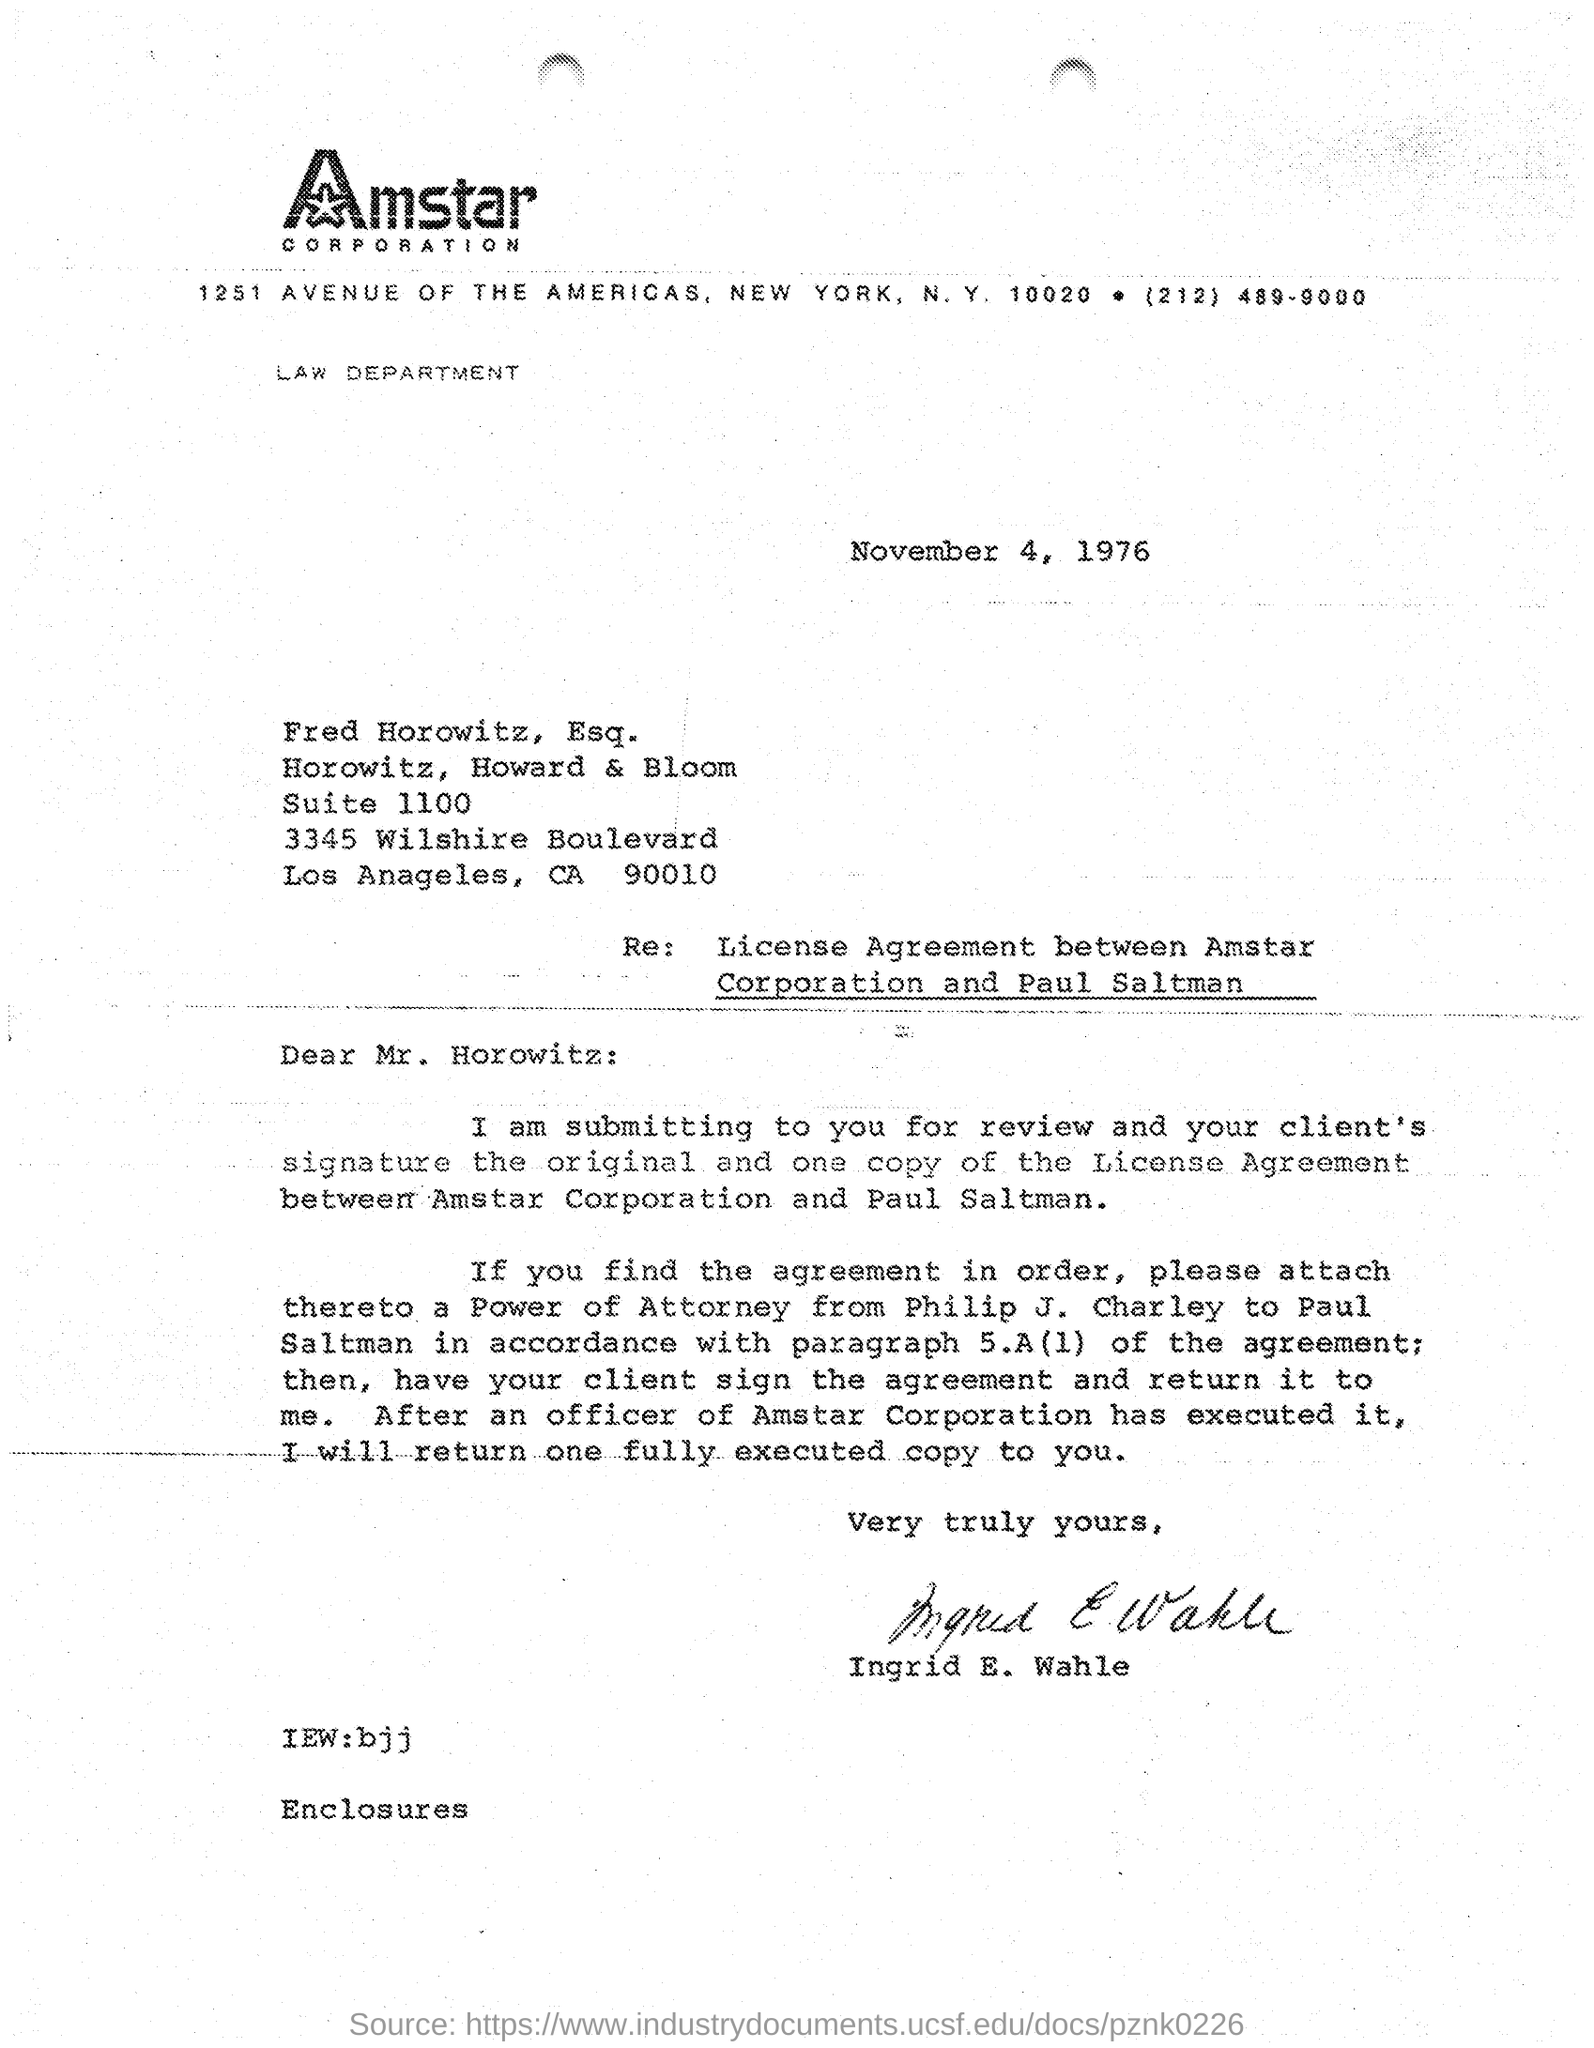Give some essential details in this illustration. The company mentioned in the letterhead is Amstar CORPORATION. The signature on the letter belongs to Ingrid E. Wahle. The date of this letter is November 4, 1976. 